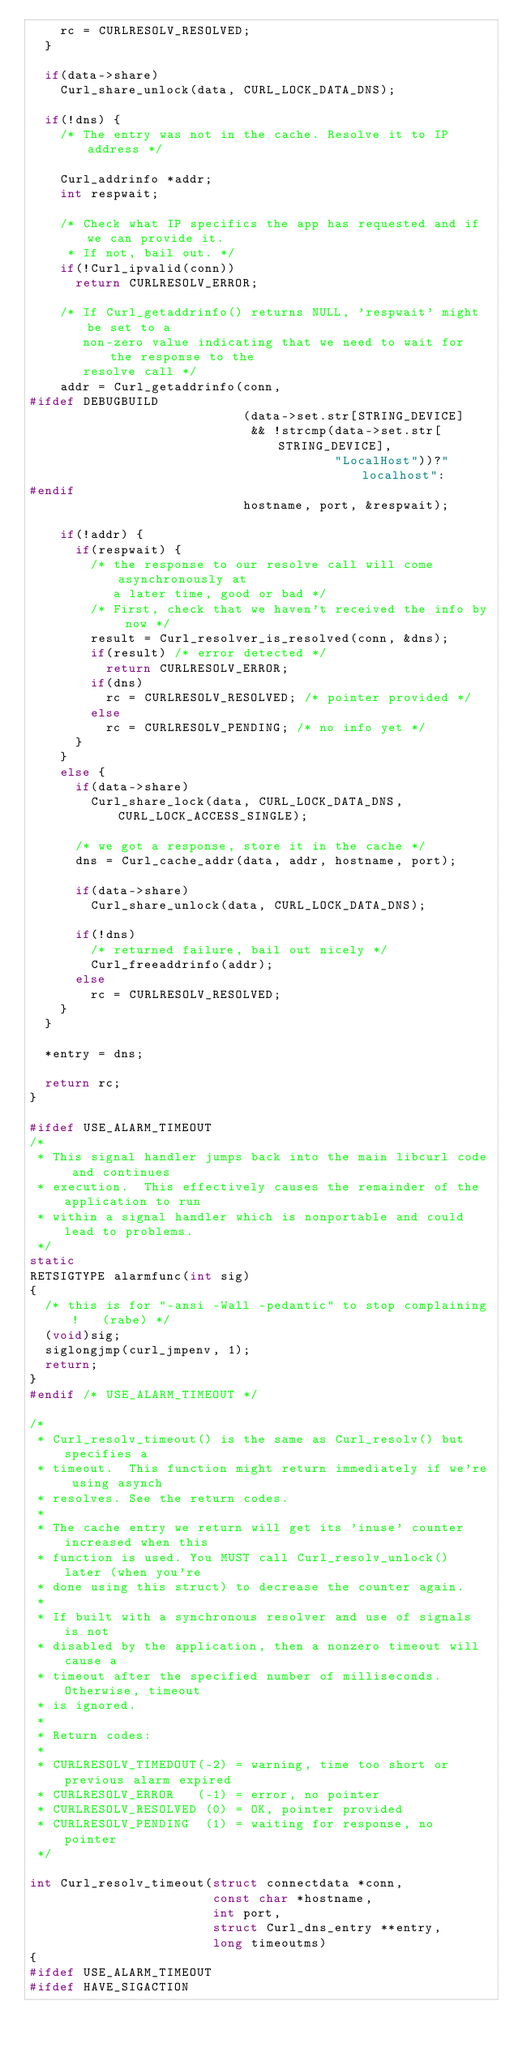Convert code to text. <code><loc_0><loc_0><loc_500><loc_500><_C_>    rc = CURLRESOLV_RESOLVED;
  }

  if(data->share)
    Curl_share_unlock(data, CURL_LOCK_DATA_DNS);

  if(!dns) {
    /* The entry was not in the cache. Resolve it to IP address */

    Curl_addrinfo *addr;
    int respwait;

    /* Check what IP specifics the app has requested and if we can provide it.
     * If not, bail out. */
    if(!Curl_ipvalid(conn))
      return CURLRESOLV_ERROR;

    /* If Curl_getaddrinfo() returns NULL, 'respwait' might be set to a
       non-zero value indicating that we need to wait for the response to the
       resolve call */
    addr = Curl_getaddrinfo(conn,
#ifdef DEBUGBUILD
                            (data->set.str[STRING_DEVICE]
                             && !strcmp(data->set.str[STRING_DEVICE],
                                        "LocalHost"))?"localhost":
#endif
                            hostname, port, &respwait);

    if(!addr) {
      if(respwait) {
        /* the response to our resolve call will come asynchronously at
           a later time, good or bad */
        /* First, check that we haven't received the info by now */
        result = Curl_resolver_is_resolved(conn, &dns);
        if(result) /* error detected */
          return CURLRESOLV_ERROR;
        if(dns)
          rc = CURLRESOLV_RESOLVED; /* pointer provided */
        else
          rc = CURLRESOLV_PENDING; /* no info yet */
      }
    }
    else {
      if(data->share)
        Curl_share_lock(data, CURL_LOCK_DATA_DNS, CURL_LOCK_ACCESS_SINGLE);

      /* we got a response, store it in the cache */
      dns = Curl_cache_addr(data, addr, hostname, port);

      if(data->share)
        Curl_share_unlock(data, CURL_LOCK_DATA_DNS);

      if(!dns)
        /* returned failure, bail out nicely */
        Curl_freeaddrinfo(addr);
      else
        rc = CURLRESOLV_RESOLVED;
    }
  }

  *entry = dns;

  return rc;
}

#ifdef USE_ALARM_TIMEOUT
/*
 * This signal handler jumps back into the main libcurl code and continues
 * execution.  This effectively causes the remainder of the application to run
 * within a signal handler which is nonportable and could lead to problems.
 */
static
RETSIGTYPE alarmfunc(int sig)
{
  /* this is for "-ansi -Wall -pedantic" to stop complaining!   (rabe) */
  (void)sig;
  siglongjmp(curl_jmpenv, 1);
  return;
}
#endif /* USE_ALARM_TIMEOUT */

/*
 * Curl_resolv_timeout() is the same as Curl_resolv() but specifies a
 * timeout.  This function might return immediately if we're using asynch
 * resolves. See the return codes.
 *
 * The cache entry we return will get its 'inuse' counter increased when this
 * function is used. You MUST call Curl_resolv_unlock() later (when you're
 * done using this struct) to decrease the counter again.
 *
 * If built with a synchronous resolver and use of signals is not
 * disabled by the application, then a nonzero timeout will cause a
 * timeout after the specified number of milliseconds. Otherwise, timeout
 * is ignored.
 *
 * Return codes:
 *
 * CURLRESOLV_TIMEDOUT(-2) = warning, time too short or previous alarm expired
 * CURLRESOLV_ERROR   (-1) = error, no pointer
 * CURLRESOLV_RESOLVED (0) = OK, pointer provided
 * CURLRESOLV_PENDING  (1) = waiting for response, no pointer
 */

int Curl_resolv_timeout(struct connectdata *conn,
                        const char *hostname,
                        int port,
                        struct Curl_dns_entry **entry,
                        long timeoutms)
{
#ifdef USE_ALARM_TIMEOUT
#ifdef HAVE_SIGACTION</code> 